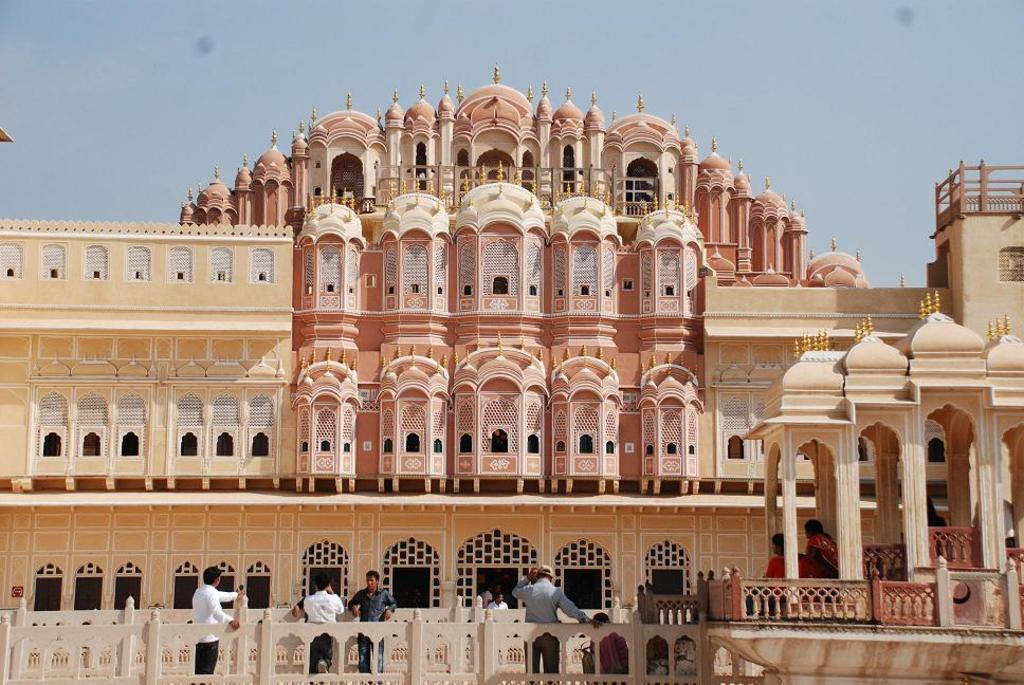What type of view is shown in the image? The image is an outside view. What structure can be seen in the image? There is a building in the image. What are the people in the image doing? There are people standing and sitting in front of the building. What is visible at the top of the image? The sky is visible at the top of the image. What color is the hair of the person sitting in front of the building? There is no information about the color of anyone's hair in the image, as the focus is on the building and the people's positions. --- Facts: 1. There is a car in the image. 2. The car is red. 3. The car has four wheels. 4. There are people inside the car. 5. The car is parked on the street. Absurd Topics: bird, flower, ocean Conversation: What is the main subject of the image? The main subject of the image is a car. What color is the car? The car is red. How many wheels does the car have? The car has four wheels. Are there any people inside the car? Yes, there are people inside the car. Where is the car located in the image? The car is parked on the street. Reasoning: Let's think step by step in order to produce the conversation. We start by identifying the main subject of the image, which is a car. Then, we describe the car's color and the number of wheels it has. Next, we mention the presence of people inside the car. Finally, we describe the car's location in the image, which is parked on the street. Absurd Question/Answer: What type of flower is growing in the ocean near the car? There is no mention of a flower or the ocean in the image, as the focus is on the car and its features. 